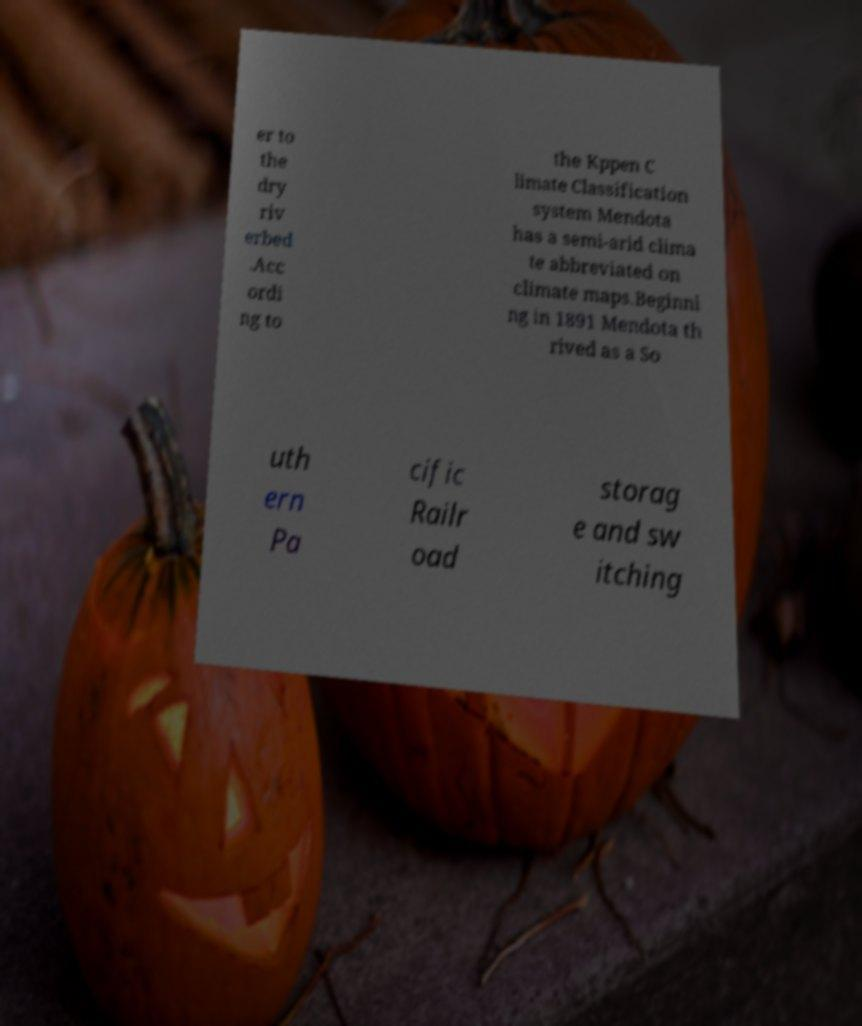There's text embedded in this image that I need extracted. Can you transcribe it verbatim? er to the dry riv erbed .Acc ordi ng to the Kppen C limate Classification system Mendota has a semi-arid clima te abbreviated on climate maps.Beginni ng in 1891 Mendota th rived as a So uth ern Pa cific Railr oad storag e and sw itching 